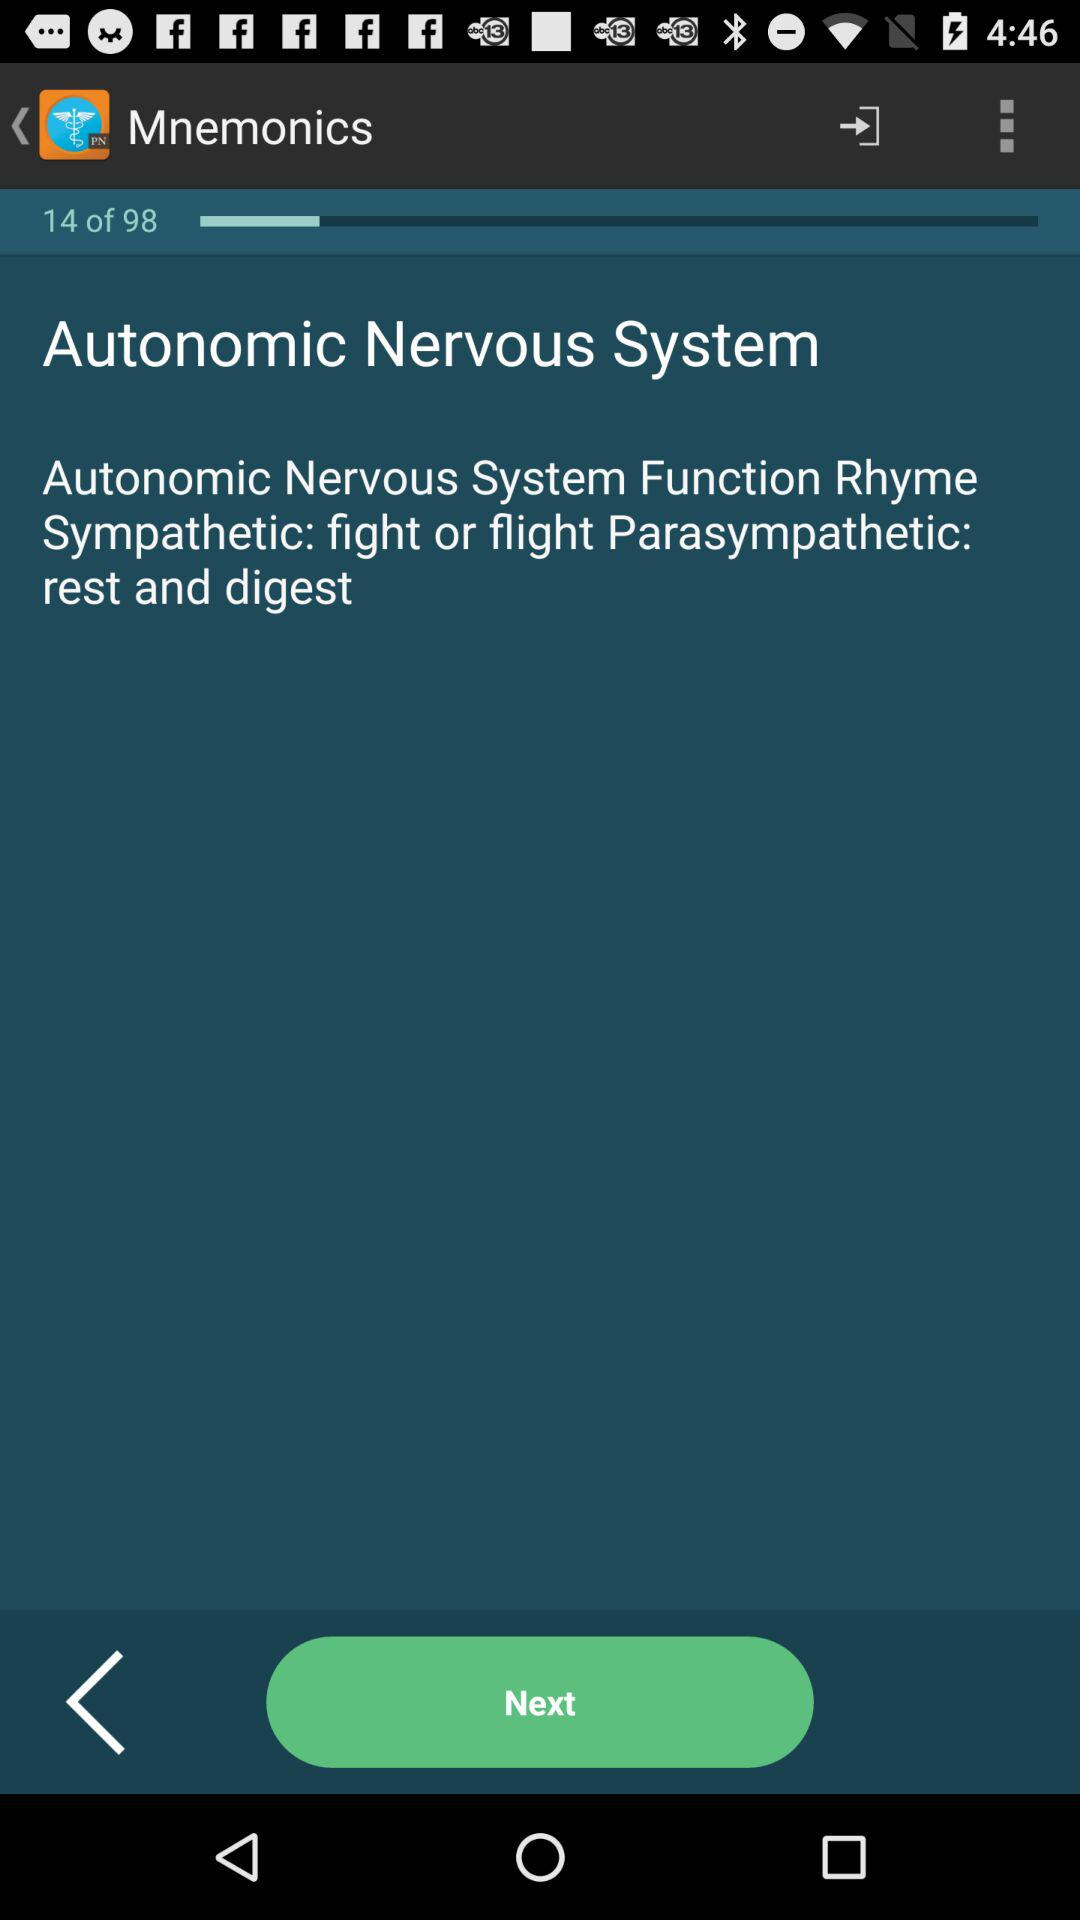On which slide number is the person? The person is on slide number 14. 